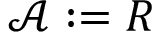<formula> <loc_0><loc_0><loc_500><loc_500>{ \mathcal { A } } \colon = R</formula> 